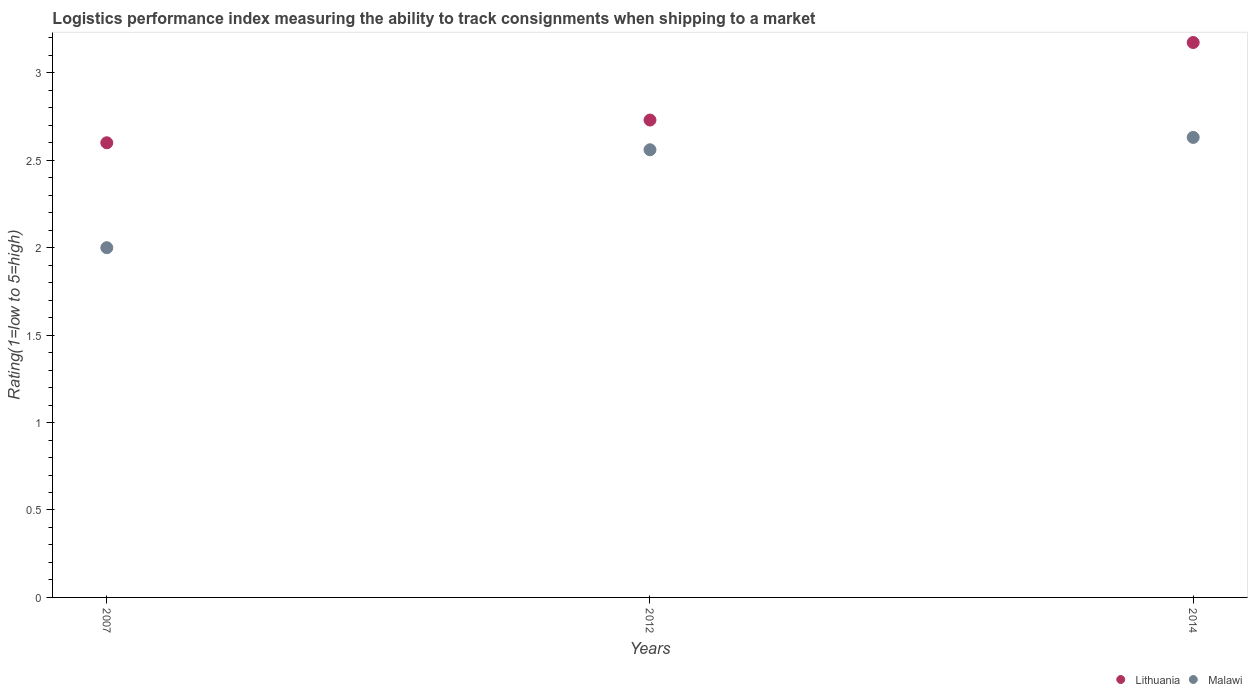How many different coloured dotlines are there?
Keep it short and to the point. 2. Is the number of dotlines equal to the number of legend labels?
Give a very brief answer. Yes. What is the Logistic performance index in Malawi in 2012?
Your response must be concise. 2.56. Across all years, what is the maximum Logistic performance index in Malawi?
Keep it short and to the point. 2.63. What is the total Logistic performance index in Malawi in the graph?
Offer a terse response. 7.19. What is the difference between the Logistic performance index in Malawi in 2012 and that in 2014?
Make the answer very short. -0.07. What is the difference between the Logistic performance index in Malawi in 2014 and the Logistic performance index in Lithuania in 2007?
Ensure brevity in your answer.  0.03. What is the average Logistic performance index in Malawi per year?
Make the answer very short. 2.4. In the year 2007, what is the difference between the Logistic performance index in Malawi and Logistic performance index in Lithuania?
Ensure brevity in your answer.  -0.6. What is the ratio of the Logistic performance index in Malawi in 2007 to that in 2012?
Keep it short and to the point. 0.78. What is the difference between the highest and the second highest Logistic performance index in Lithuania?
Keep it short and to the point. 0.44. What is the difference between the highest and the lowest Logistic performance index in Malawi?
Offer a terse response. 0.63. Is the Logistic performance index in Malawi strictly greater than the Logistic performance index in Lithuania over the years?
Your response must be concise. No. How many dotlines are there?
Provide a succinct answer. 2. How many years are there in the graph?
Provide a succinct answer. 3. Are the values on the major ticks of Y-axis written in scientific E-notation?
Give a very brief answer. No. Does the graph contain any zero values?
Provide a succinct answer. No. How are the legend labels stacked?
Your answer should be compact. Horizontal. What is the title of the graph?
Provide a short and direct response. Logistics performance index measuring the ability to track consignments when shipping to a market. What is the label or title of the X-axis?
Provide a succinct answer. Years. What is the label or title of the Y-axis?
Your response must be concise. Rating(1=low to 5=high). What is the Rating(1=low to 5=high) in Lithuania in 2007?
Give a very brief answer. 2.6. What is the Rating(1=low to 5=high) of Malawi in 2007?
Your answer should be compact. 2. What is the Rating(1=low to 5=high) of Lithuania in 2012?
Give a very brief answer. 2.73. What is the Rating(1=low to 5=high) in Malawi in 2012?
Ensure brevity in your answer.  2.56. What is the Rating(1=low to 5=high) of Lithuania in 2014?
Your answer should be compact. 3.17. What is the Rating(1=low to 5=high) of Malawi in 2014?
Make the answer very short. 2.63. Across all years, what is the maximum Rating(1=low to 5=high) of Lithuania?
Your response must be concise. 3.17. Across all years, what is the maximum Rating(1=low to 5=high) in Malawi?
Your response must be concise. 2.63. What is the total Rating(1=low to 5=high) in Lithuania in the graph?
Your answer should be very brief. 8.5. What is the total Rating(1=low to 5=high) of Malawi in the graph?
Offer a very short reply. 7.19. What is the difference between the Rating(1=low to 5=high) in Lithuania in 2007 and that in 2012?
Ensure brevity in your answer.  -0.13. What is the difference between the Rating(1=low to 5=high) of Malawi in 2007 and that in 2012?
Provide a short and direct response. -0.56. What is the difference between the Rating(1=low to 5=high) in Lithuania in 2007 and that in 2014?
Give a very brief answer. -0.57. What is the difference between the Rating(1=low to 5=high) in Malawi in 2007 and that in 2014?
Your answer should be compact. -0.63. What is the difference between the Rating(1=low to 5=high) in Lithuania in 2012 and that in 2014?
Your answer should be very brief. -0.44. What is the difference between the Rating(1=low to 5=high) of Malawi in 2012 and that in 2014?
Make the answer very short. -0.07. What is the difference between the Rating(1=low to 5=high) of Lithuania in 2007 and the Rating(1=low to 5=high) of Malawi in 2014?
Ensure brevity in your answer.  -0.03. What is the difference between the Rating(1=low to 5=high) in Lithuania in 2012 and the Rating(1=low to 5=high) in Malawi in 2014?
Keep it short and to the point. 0.1. What is the average Rating(1=low to 5=high) in Lithuania per year?
Provide a short and direct response. 2.83. What is the average Rating(1=low to 5=high) in Malawi per year?
Your response must be concise. 2.4. In the year 2012, what is the difference between the Rating(1=low to 5=high) in Lithuania and Rating(1=low to 5=high) in Malawi?
Your answer should be very brief. 0.17. In the year 2014, what is the difference between the Rating(1=low to 5=high) in Lithuania and Rating(1=low to 5=high) in Malawi?
Make the answer very short. 0.54. What is the ratio of the Rating(1=low to 5=high) of Lithuania in 2007 to that in 2012?
Provide a short and direct response. 0.95. What is the ratio of the Rating(1=low to 5=high) of Malawi in 2007 to that in 2012?
Make the answer very short. 0.78. What is the ratio of the Rating(1=low to 5=high) of Lithuania in 2007 to that in 2014?
Make the answer very short. 0.82. What is the ratio of the Rating(1=low to 5=high) of Malawi in 2007 to that in 2014?
Keep it short and to the point. 0.76. What is the ratio of the Rating(1=low to 5=high) in Lithuania in 2012 to that in 2014?
Keep it short and to the point. 0.86. What is the ratio of the Rating(1=low to 5=high) in Malawi in 2012 to that in 2014?
Offer a very short reply. 0.97. What is the difference between the highest and the second highest Rating(1=low to 5=high) in Lithuania?
Provide a short and direct response. 0.44. What is the difference between the highest and the second highest Rating(1=low to 5=high) of Malawi?
Your answer should be very brief. 0.07. What is the difference between the highest and the lowest Rating(1=low to 5=high) in Lithuania?
Your answer should be very brief. 0.57. What is the difference between the highest and the lowest Rating(1=low to 5=high) in Malawi?
Offer a very short reply. 0.63. 